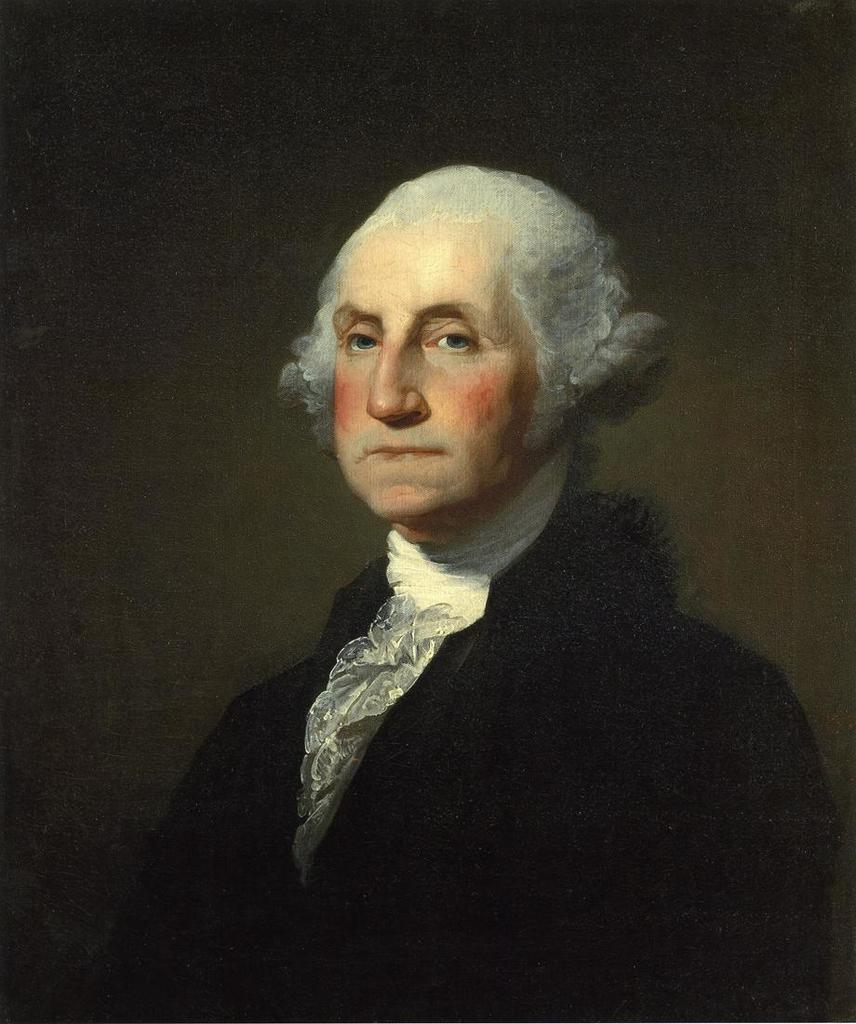Who is present in the image? There is a man in the image. What is the man wearing? The man is wearing a black dress. What can be seen in the background of the image? The background of the image is black. What type of silverware is the man using in the image? There is no silverware present in the image; the man is wearing a black dress in front of a black background. 